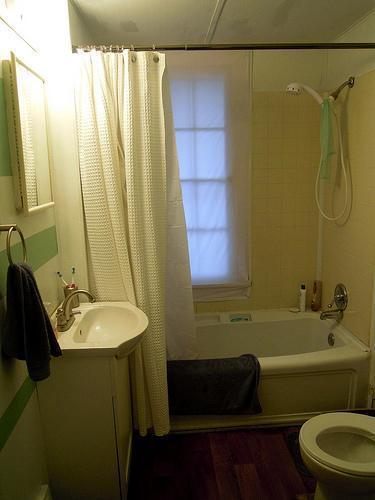How many sinks are visible?
Give a very brief answer. 1. How many windows are there?
Give a very brief answer. 1. 